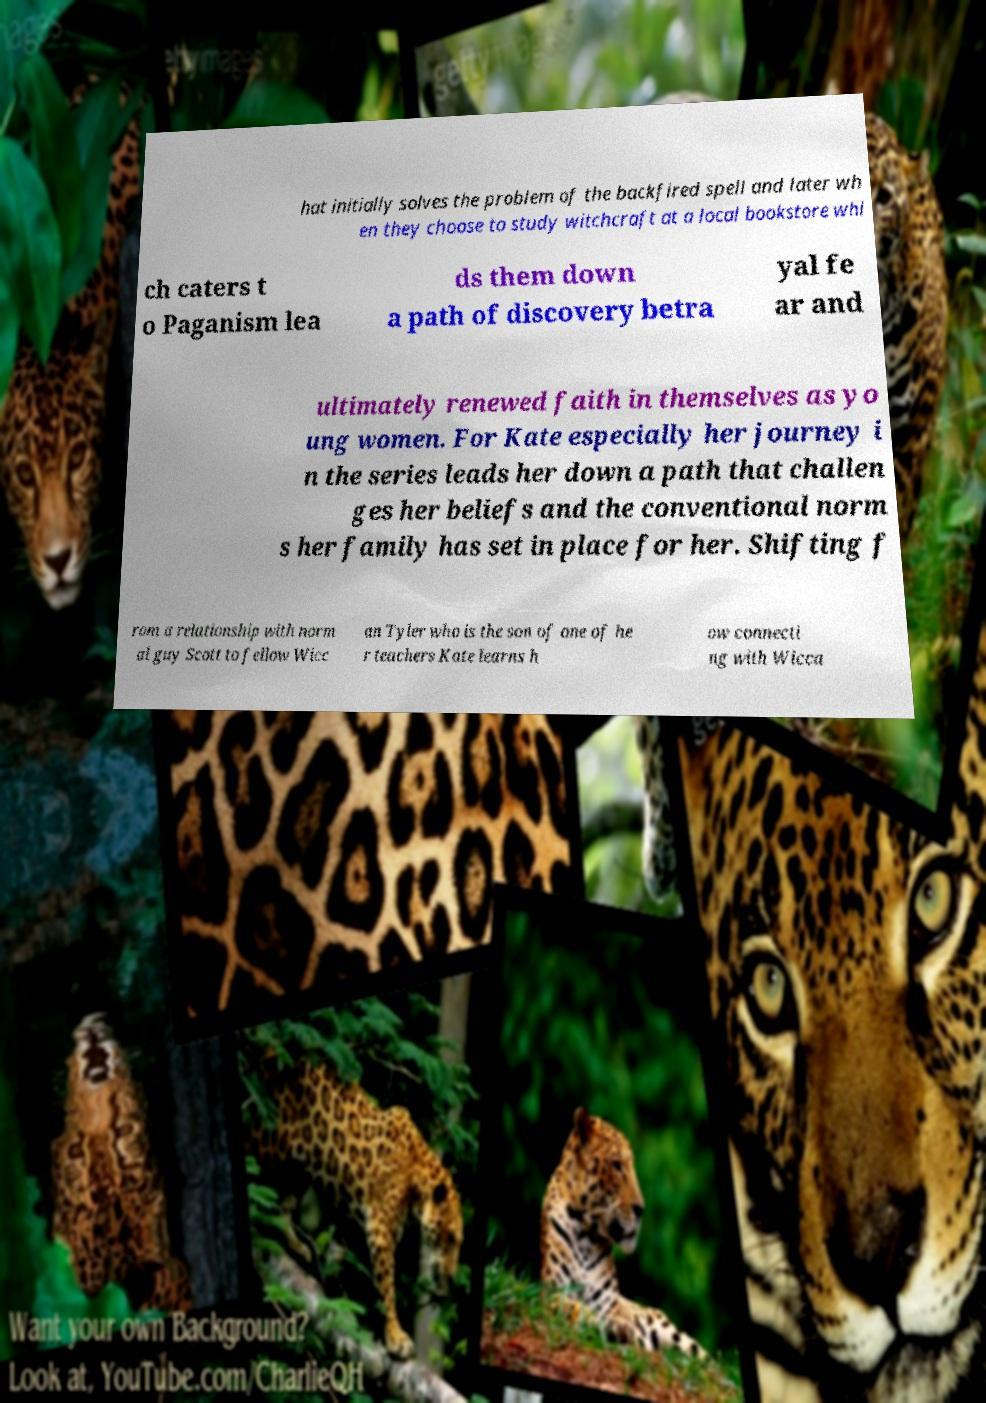What messages or text are displayed in this image? I need them in a readable, typed format. hat initially solves the problem of the backfired spell and later wh en they choose to study witchcraft at a local bookstore whi ch caters t o Paganism lea ds them down a path of discovery betra yal fe ar and ultimately renewed faith in themselves as yo ung women. For Kate especially her journey i n the series leads her down a path that challen ges her beliefs and the conventional norm s her family has set in place for her. Shifting f rom a relationship with norm al guy Scott to fellow Wicc an Tyler who is the son of one of he r teachers Kate learns h ow connecti ng with Wicca 